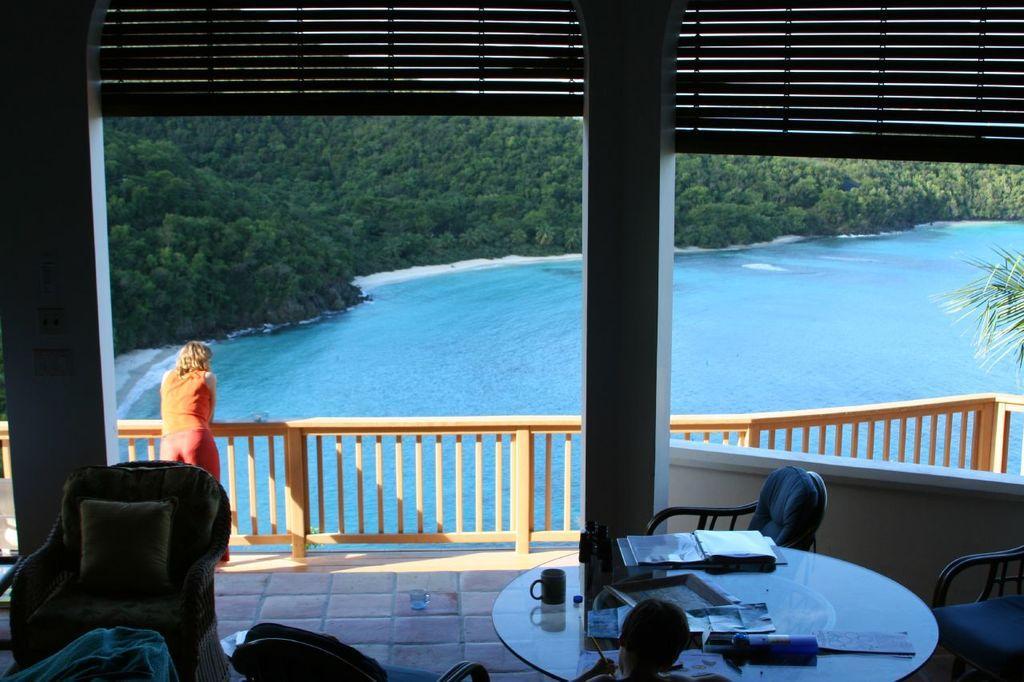In one or two sentences, can you explain what this image depicts? In this image i can see a in side view of a building and a woman stand in front of a lake in front of a lake there are trees visible ,on the right side there is a table ,on the table there are some objects kept and a head visible and there is a chair on the left side. 